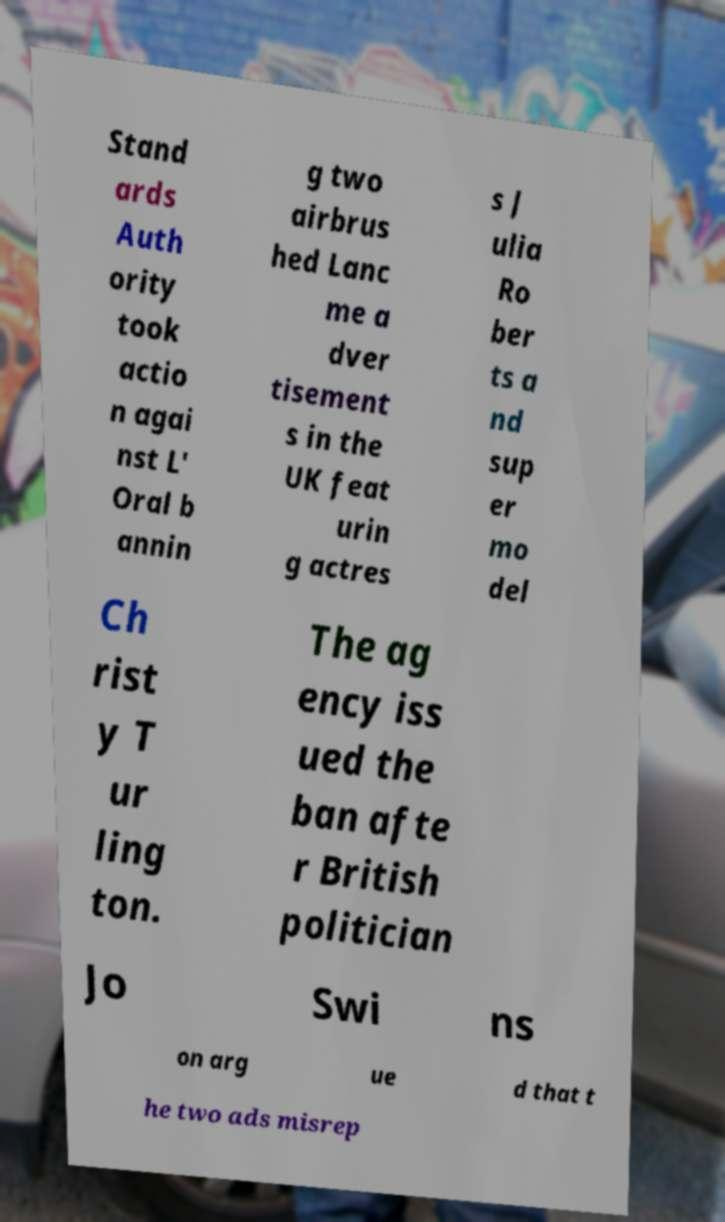Can you accurately transcribe the text from the provided image for me? Stand ards Auth ority took actio n agai nst L' Oral b annin g two airbrus hed Lanc me a dver tisement s in the UK feat urin g actres s J ulia Ro ber ts a nd sup er mo del Ch rist y T ur ling ton. The ag ency iss ued the ban afte r British politician Jo Swi ns on arg ue d that t he two ads misrep 